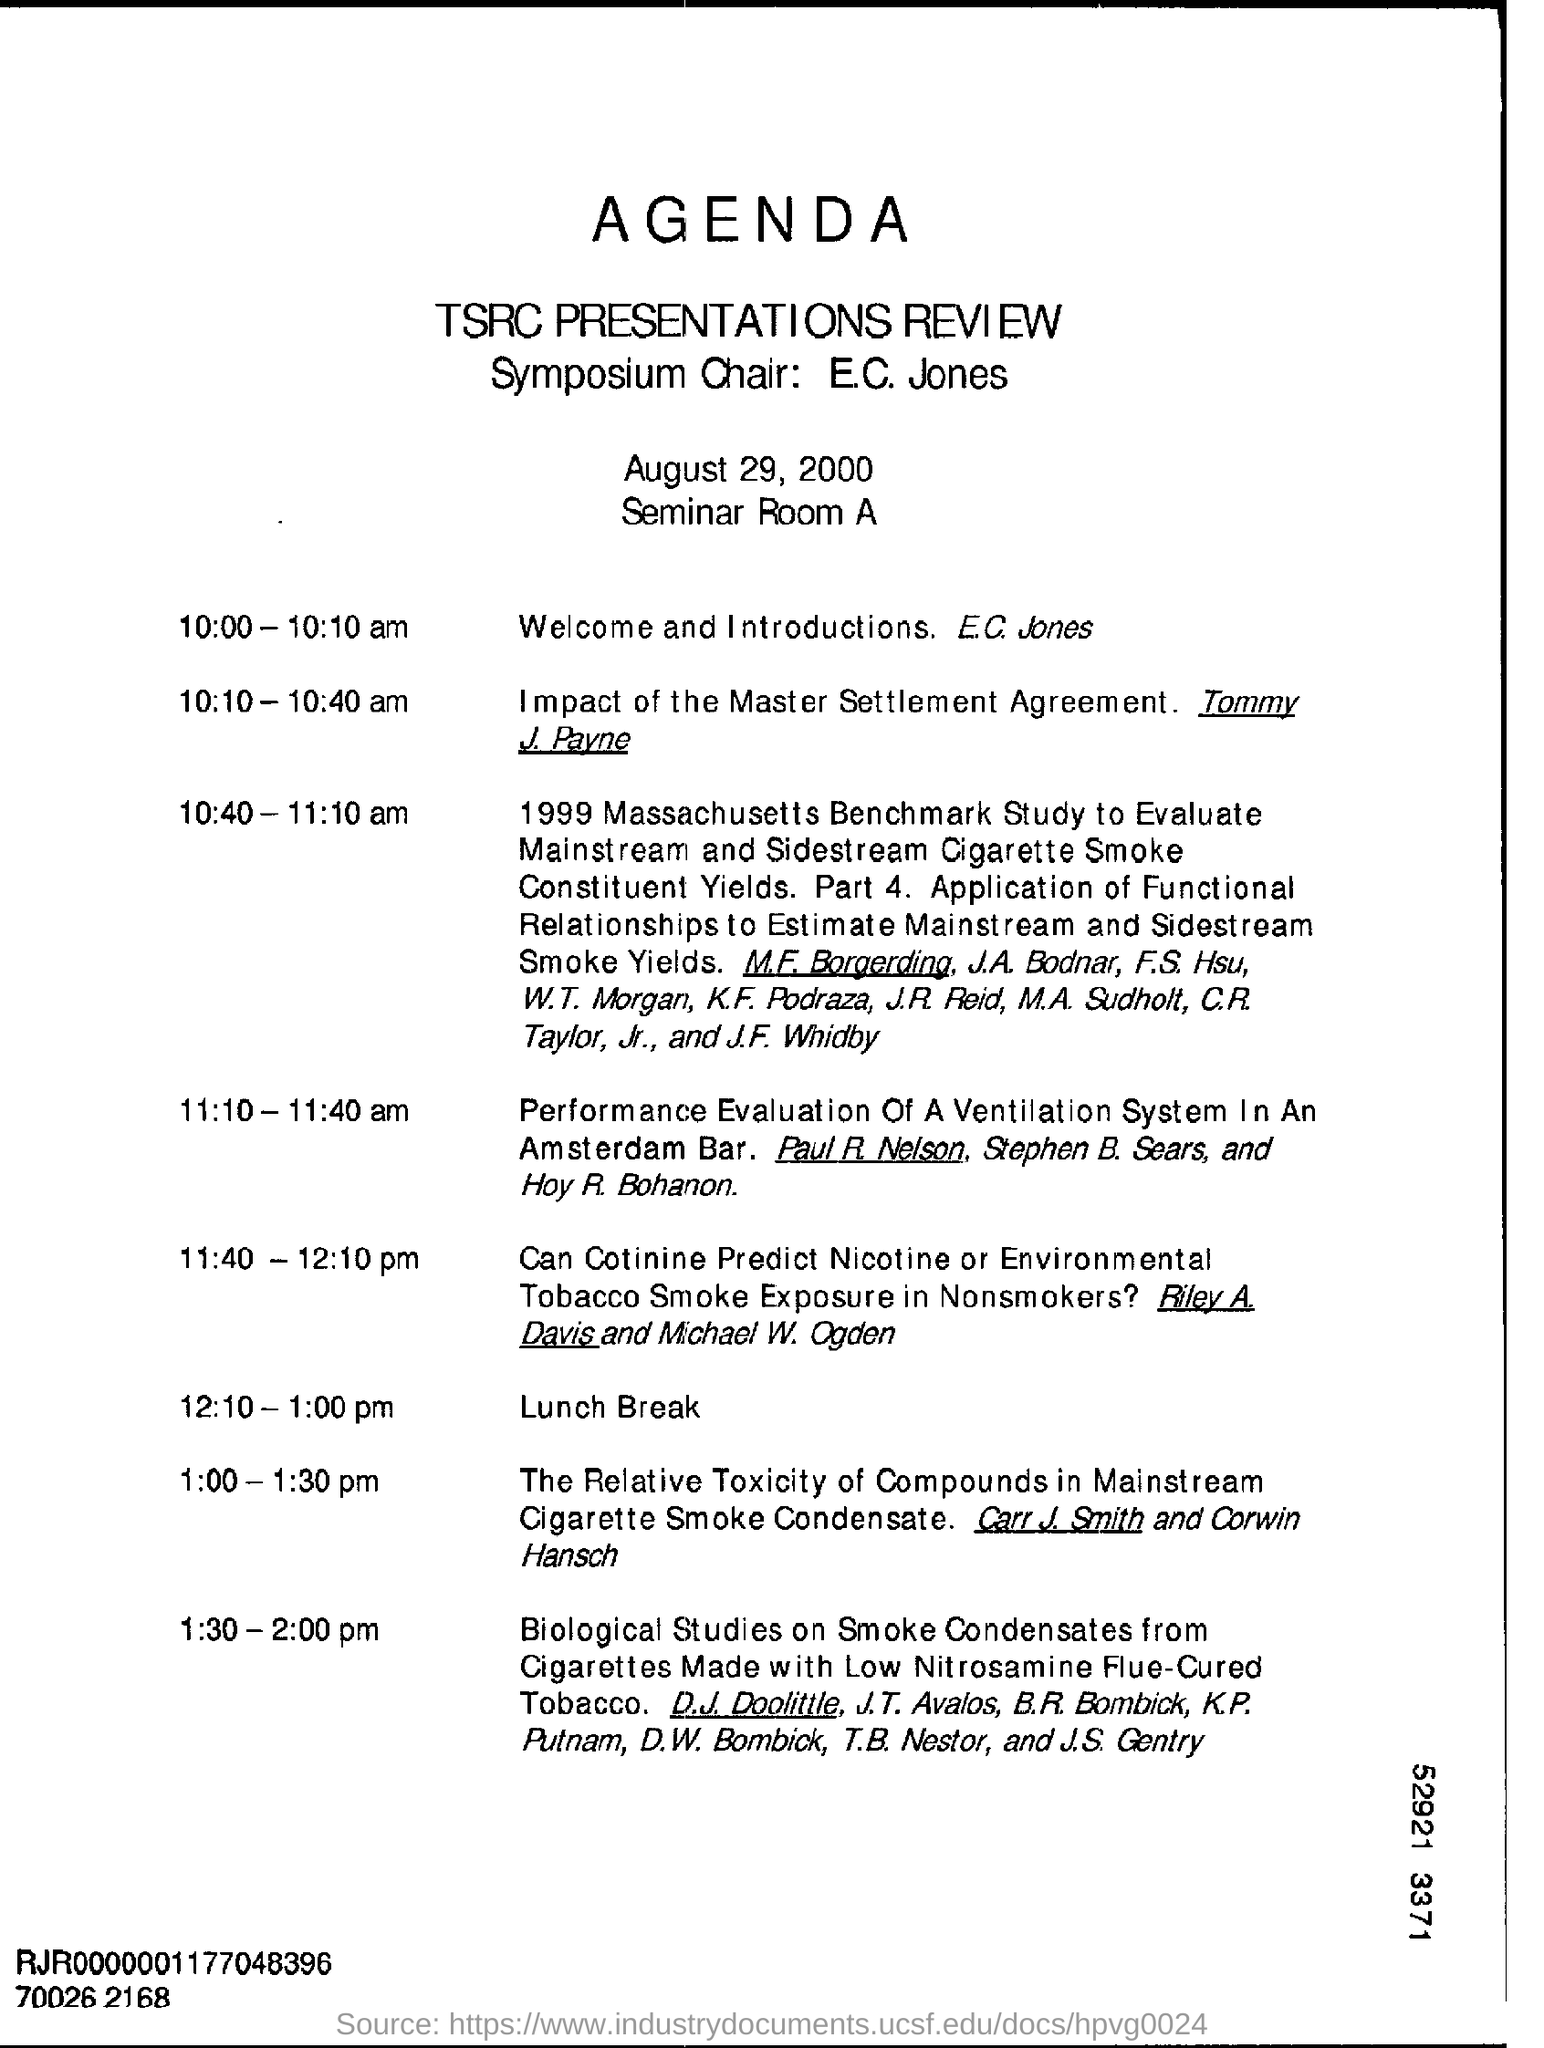Who is the symposium chairman?
Ensure brevity in your answer.  E.C. Jones. When is the agenda dated ?
Your answer should be very brief. August 29, 2000. What is the venue of tsrc presentations review ?
Provide a short and direct response. Seminar Room A. Who is giving the welcome and introductions ?
Give a very brief answer. E.C. Jones. 